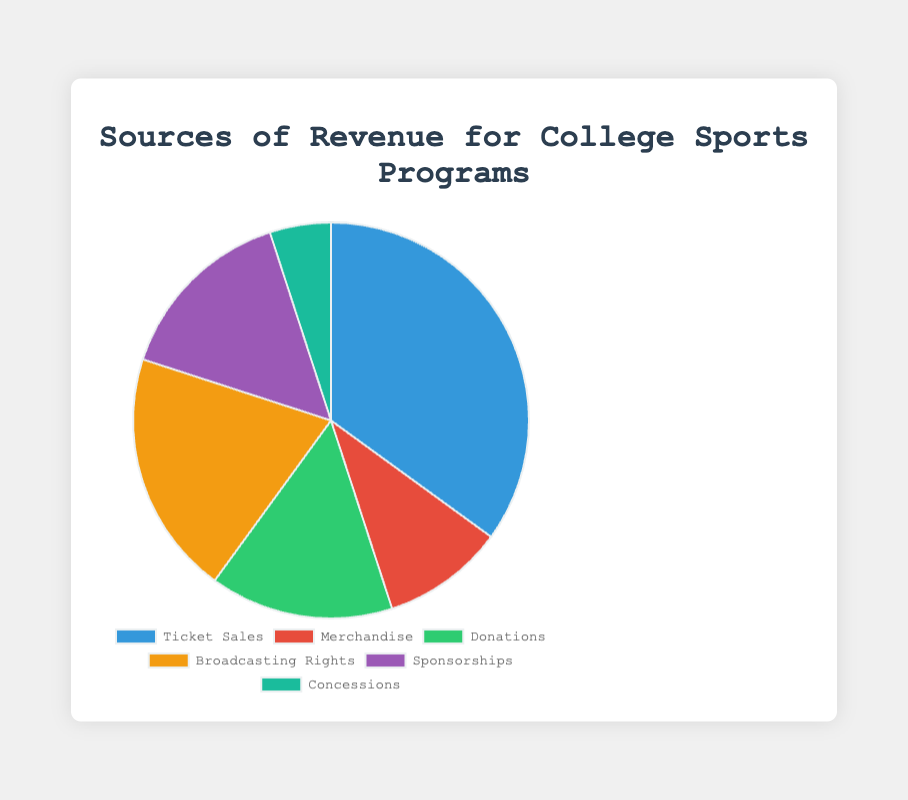What's the largest source of revenue for college sports programs? The pie chart shows different sources of revenue, and the segment with the largest percentage represents the largest source. The largest percentage is 35%, which corresponds to Ticket Sales.
Answer: Ticket Sales Which sources contribute equally to the revenue? From the chart, we can see that Donations and Sponsorships each contribute 15% to the overall revenue, making them equal contributors.
Answer: Donations and Sponsorships How much higher is the percentage contribution of Ticket Sales compared to Concessions? Ticket Sales is 35% and Concessions is 5%. To find the difference, subtract the percentage of Concessions from Ticket Sales: 35% - 5% = 30%.
Answer: 30% Are the combined contributions of Donations and Sponsorships more than the contribution from Broadcasting Rights? Donations contribute 15% and Sponsorships contribute 15%. Combined, they contribute 15% + 15% = 30%. Broadcasting Rights contribute 20%. Since 30% is greater than 20%, the combined contribution of Donations and Sponsorships is indeed more.
Answer: Yes Which source has the smallest contribution to the revenue? The smallest percentage segment in the pie chart is 5%, which represents Concessions.
Answer: Concessions What's the average percentage contribution of all revenue sources? Add all the percentages together (35% + 10% + 15% + 20% + 15% + 5% = 100%) and then divide by the number of sources (6). So, the average is 100% / 6 = 16.67%.
Answer: 16.67% Which revenue source is represented by the red color in the pie chart? In the description of the data for the pie chart, the segment colored red corresponds to Merchandise.
Answer: Merchandise Is the revenue from Donations less than that from Broadcasting Rights and Sponsorships combined? Donations contribute 15%. Broadcasting Rights and Sponsorships combined contribute 20% + 15% = 35%. Since 15% is less than 35%, revenue from Donations is indeed less.
Answer: Yes How does the revenue from Broadcasting Rights compare to the revenue from Merchandise? Broadcasting Rights contribute 20% and Merchandise contributes 10%. Since 20% is greater than 10%, Broadcasting Rights generate more revenue than Merchandise.
Answer: Greater 